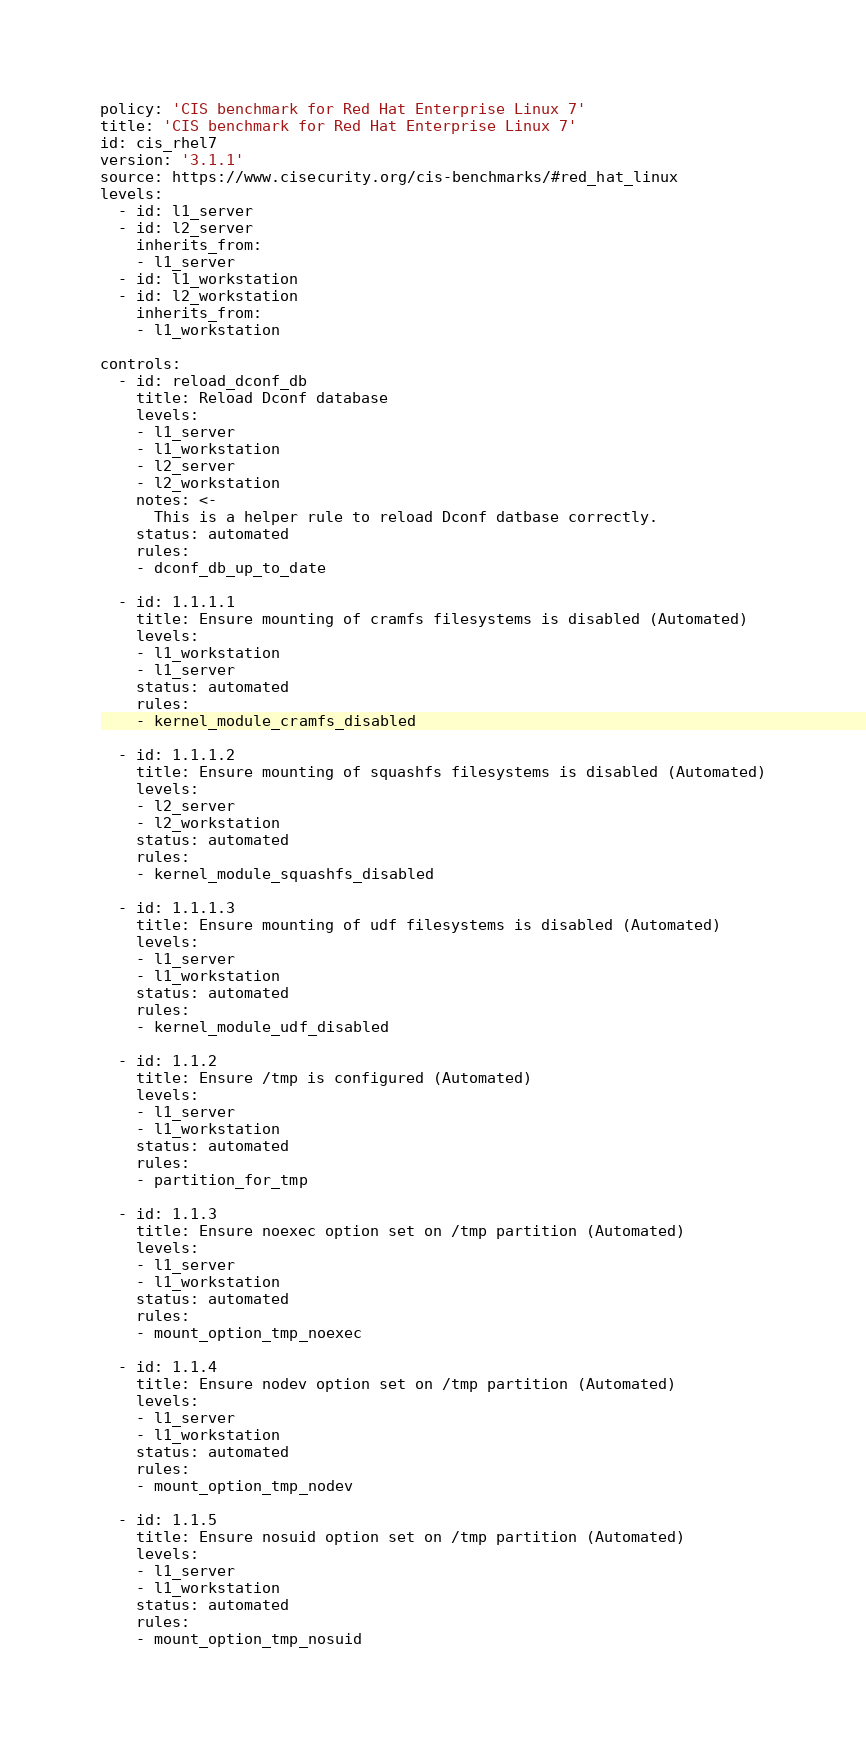<code> <loc_0><loc_0><loc_500><loc_500><_YAML_>policy: 'CIS benchmark for Red Hat Enterprise Linux 7'
title: 'CIS benchmark for Red Hat Enterprise Linux 7'
id: cis_rhel7
version: '3.1.1'
source: https://www.cisecurity.org/cis-benchmarks/#red_hat_linux
levels:
  - id: l1_server
  - id: l2_server
    inherits_from:
    - l1_server
  - id: l1_workstation
  - id: l2_workstation
    inherits_from:
    - l1_workstation

controls:
  - id: reload_dconf_db
    title: Reload Dconf database
    levels:
    - l1_server
    - l1_workstation
    - l2_server
    - l2_workstation
    notes: <-
      This is a helper rule to reload Dconf datbase correctly.
    status: automated
    rules:
    - dconf_db_up_to_date

  - id: 1.1.1.1
    title: Ensure mounting of cramfs filesystems is disabled (Automated)
    levels:
    - l1_workstation
    - l1_server
    status: automated
    rules:
    - kernel_module_cramfs_disabled

  - id: 1.1.1.2
    title: Ensure mounting of squashfs filesystems is disabled (Automated)
    levels:
    - l2_server
    - l2_workstation
    status: automated
    rules:
    - kernel_module_squashfs_disabled

  - id: 1.1.1.3
    title: Ensure mounting of udf filesystems is disabled (Automated)
    levels:
    - l1_server
    - l1_workstation
    status: automated
    rules:
    - kernel_module_udf_disabled

  - id: 1.1.2
    title: Ensure /tmp is configured (Automated)
    levels:
    - l1_server
    - l1_workstation
    status: automated
    rules:
    - partition_for_tmp

  - id: 1.1.3
    title: Ensure noexec option set on /tmp partition (Automated)
    levels:
    - l1_server
    - l1_workstation
    status: automated
    rules:
    - mount_option_tmp_noexec

  - id: 1.1.4
    title: Ensure nodev option set on /tmp partition (Automated)
    levels:
    - l1_server
    - l1_workstation
    status: automated
    rules:
    - mount_option_tmp_nodev

  - id: 1.1.5
    title: Ensure nosuid option set on /tmp partition (Automated)
    levels:
    - l1_server
    - l1_workstation
    status: automated
    rules:
    - mount_option_tmp_nosuid
</code> 